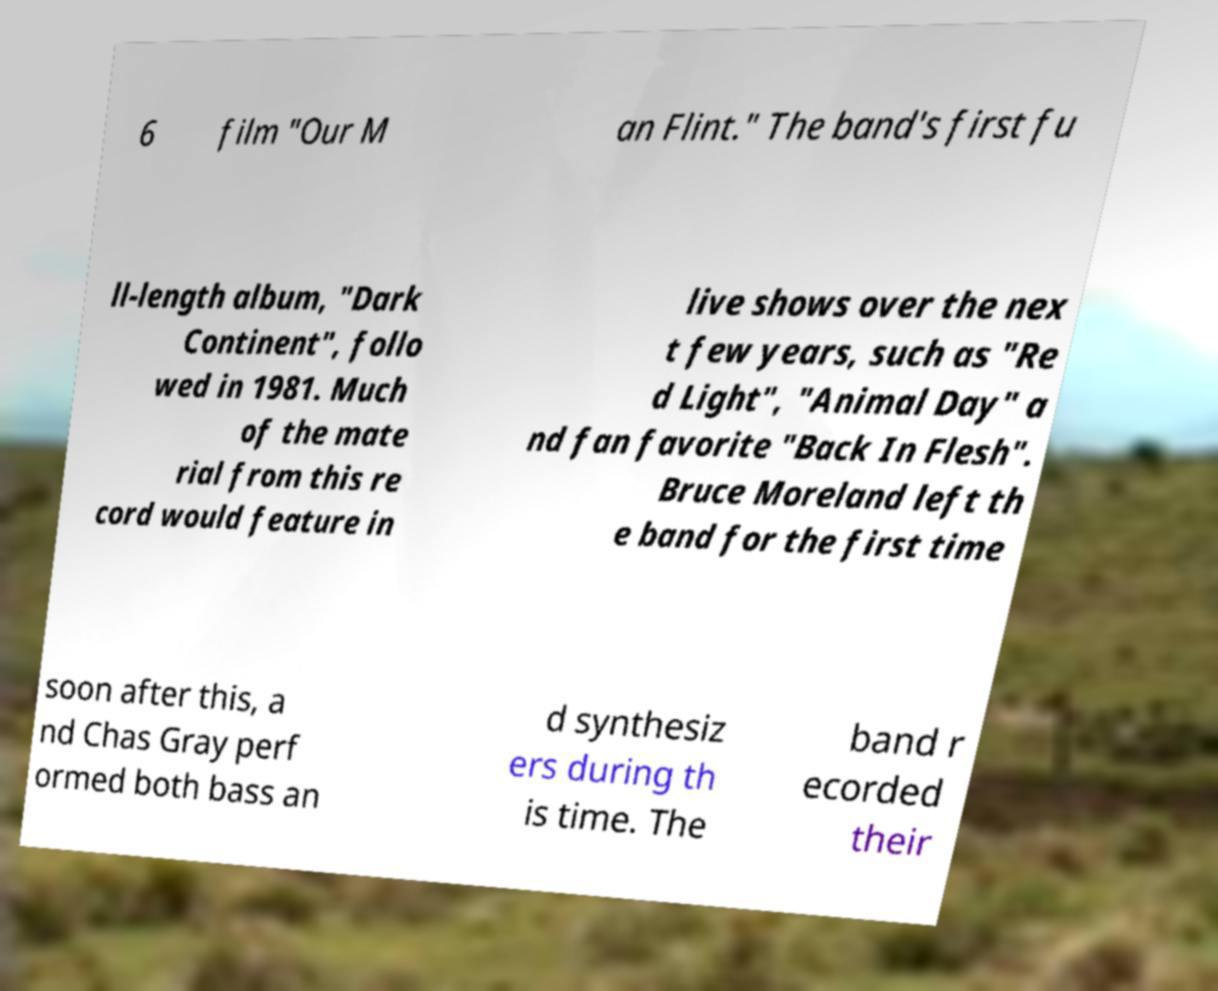Please read and relay the text visible in this image. What does it say? 6 film "Our M an Flint." The band's first fu ll-length album, "Dark Continent", follo wed in 1981. Much of the mate rial from this re cord would feature in live shows over the nex t few years, such as "Re d Light", "Animal Day" a nd fan favorite "Back In Flesh". Bruce Moreland left th e band for the first time soon after this, a nd Chas Gray perf ormed both bass an d synthesiz ers during th is time. The band r ecorded their 